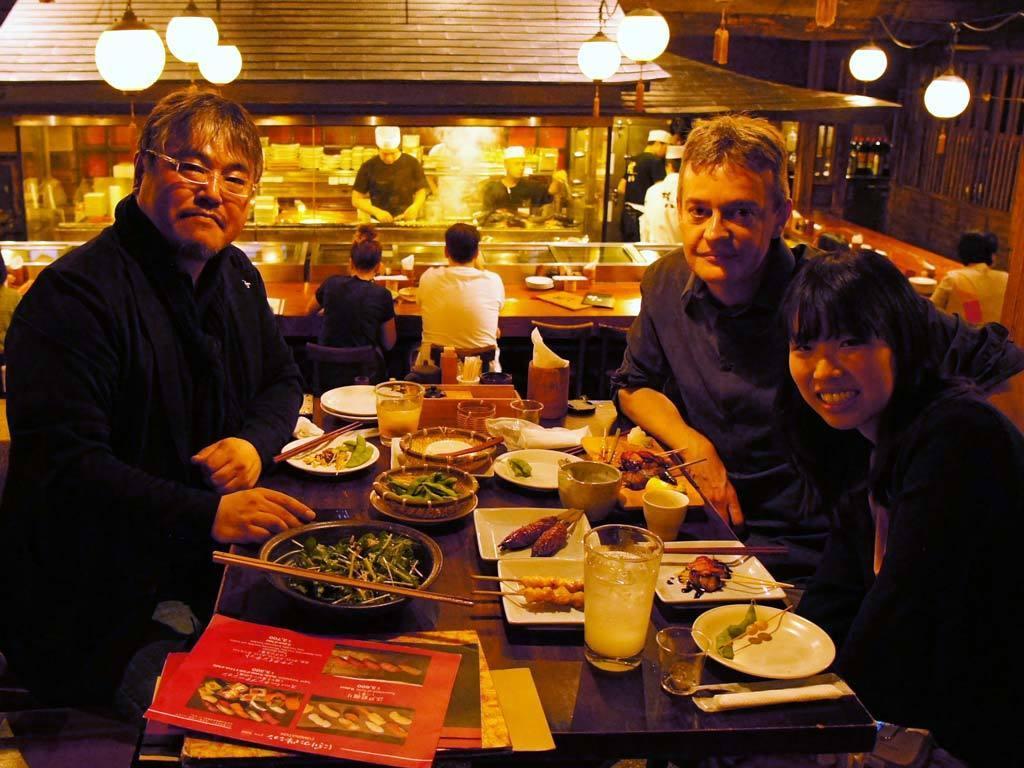Describe this image in one or two sentences. In this image there are food items on the plates and in the bowls, there are cards, chop sticks, glasses, tissues box and some other items on the table, there are three persons sitting , and in the background there are Chinese lanterns hanging, group of people , in which two persons are sitting on the chairs, and there are some objects on the tables. 